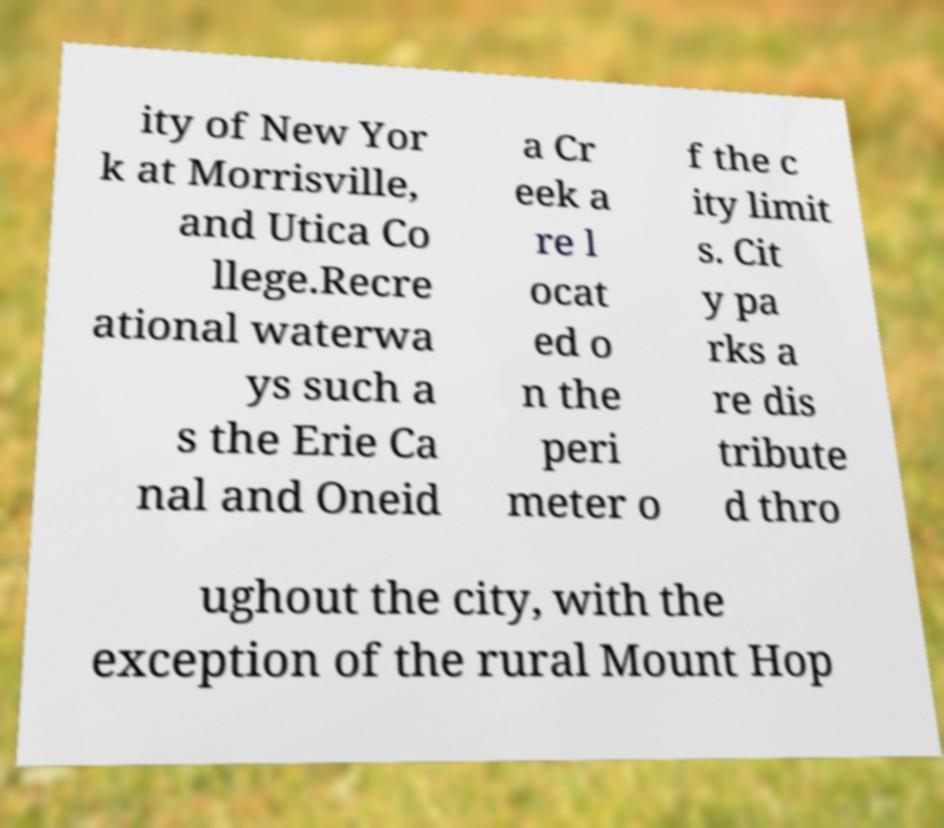Please read and relay the text visible in this image. What does it say? ity of New Yor k at Morrisville, and Utica Co llege.Recre ational waterwa ys such a s the Erie Ca nal and Oneid a Cr eek a re l ocat ed o n the peri meter o f the c ity limit s. Cit y pa rks a re dis tribute d thro ughout the city, with the exception of the rural Mount Hop 